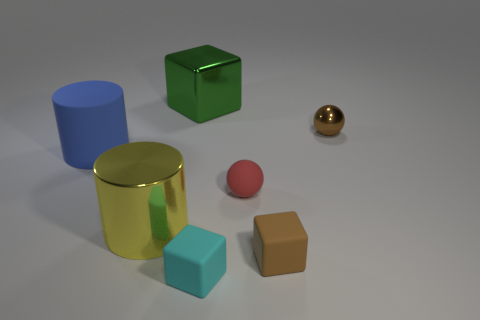Are there any large green things made of the same material as the cyan cube?
Make the answer very short. No. There is a cyan thing on the left side of the small brown rubber object; what is its material?
Give a very brief answer. Rubber. Does the small cube right of the small red sphere have the same color as the sphere that is behind the small red object?
Provide a short and direct response. Yes. What color is the other matte cube that is the same size as the brown rubber block?
Offer a very short reply. Cyan. What number of other things are the same shape as the big green metallic thing?
Your answer should be very brief. 2. There is a brown thing that is on the left side of the tiny metallic sphere; what size is it?
Your response must be concise. Small. There is a metallic thing to the left of the big metallic cube; how many objects are in front of it?
Provide a short and direct response. 2. What number of other objects are there of the same size as the brown rubber block?
Ensure brevity in your answer.  3. There is a brown thing behind the small red rubber thing; is it the same shape as the red object?
Keep it short and to the point. Yes. How many rubber things are behind the tiny cyan object and in front of the large yellow thing?
Offer a terse response. 1. 